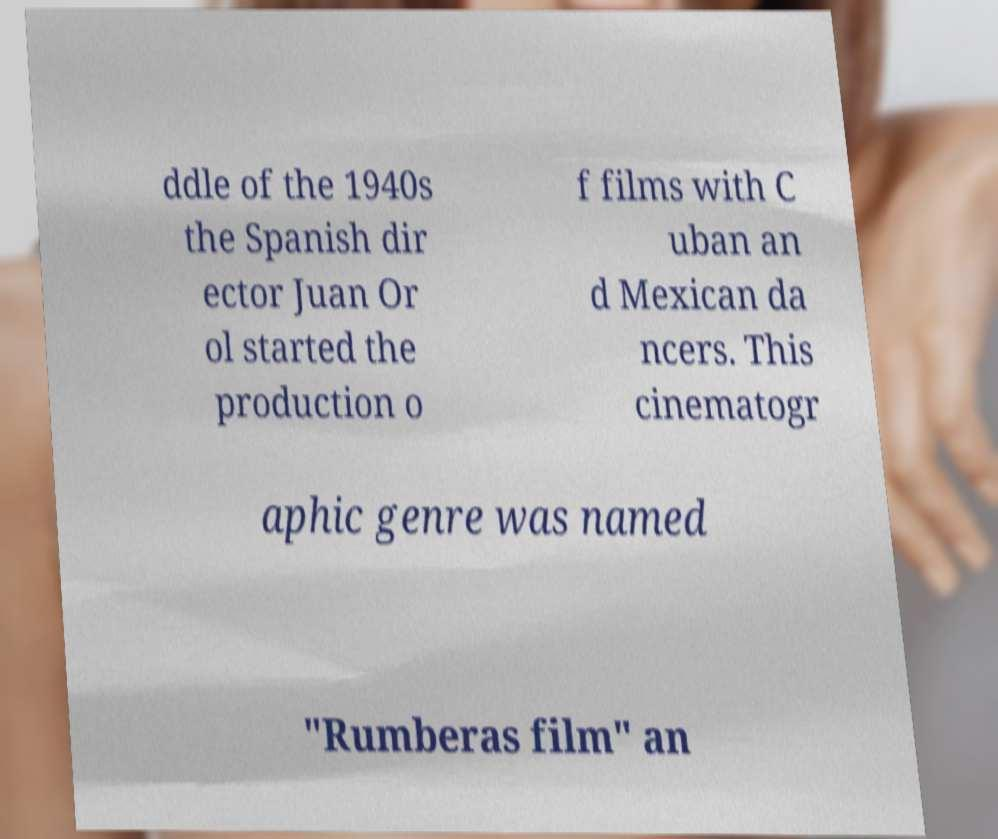Please read and relay the text visible in this image. What does it say? ddle of the 1940s the Spanish dir ector Juan Or ol started the production o f films with C uban an d Mexican da ncers. This cinematogr aphic genre was named "Rumberas film" an 